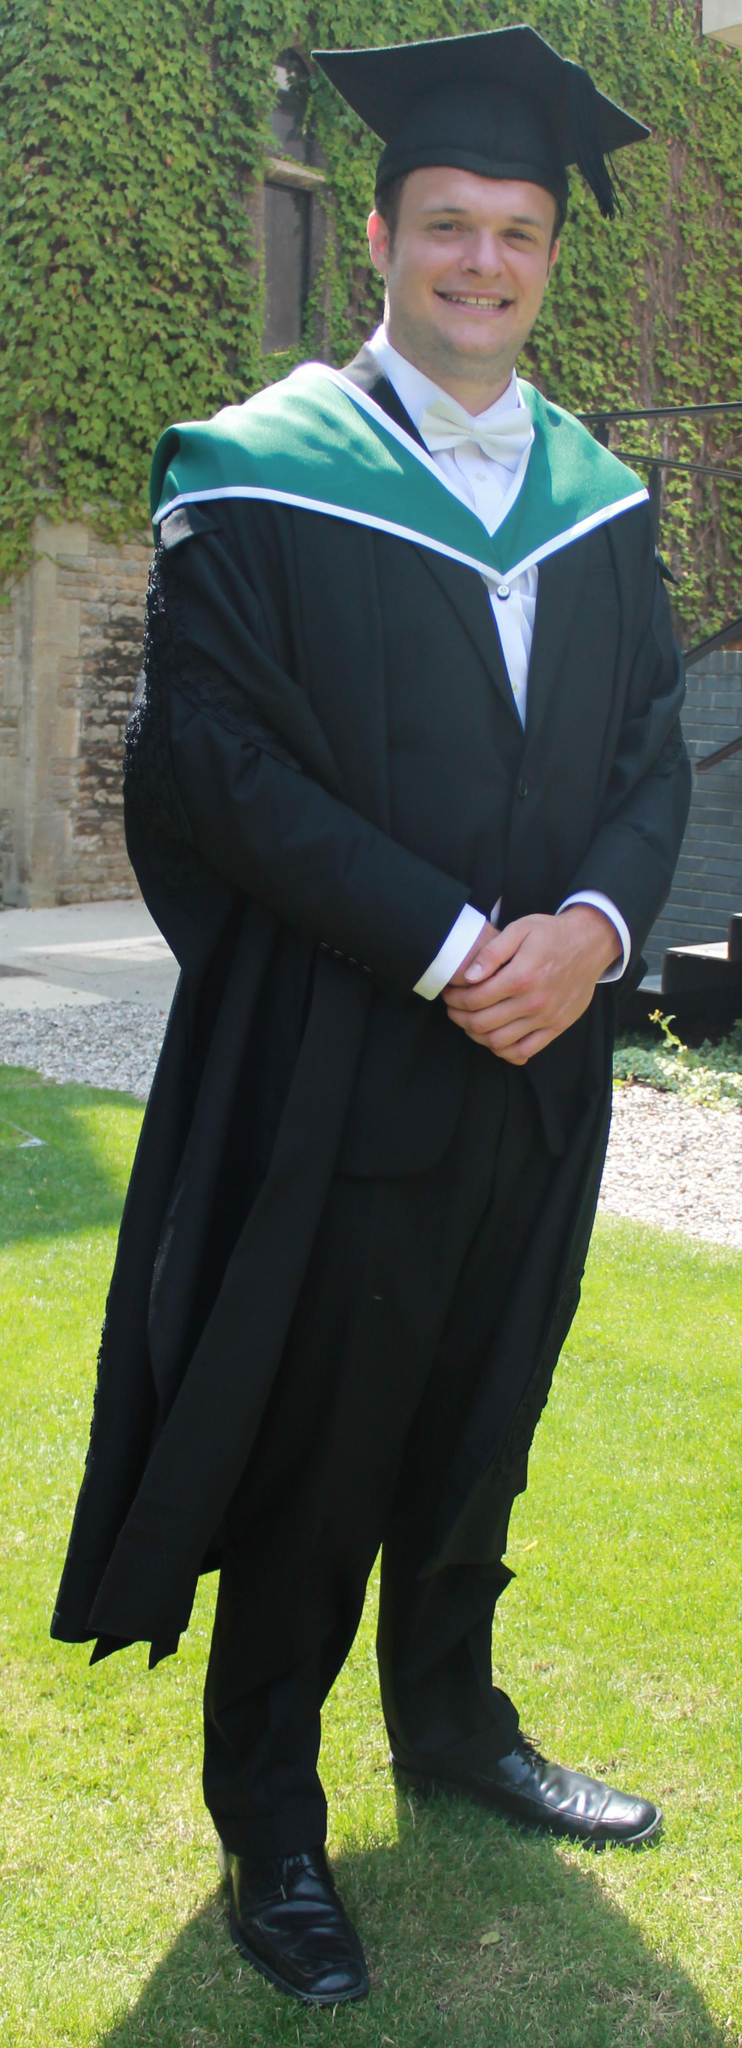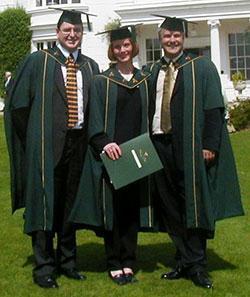The first image is the image on the left, the second image is the image on the right. For the images displayed, is the sentence "In the right image, the tassle of a graduate's hat is on the left side of the image." factually correct? Answer yes or no. No. The first image is the image on the left, the second image is the image on the right. Given the left and right images, does the statement "Each image contains one female graduate, and one image shows a graduate who is not facing forward." hold true? Answer yes or no. No. 